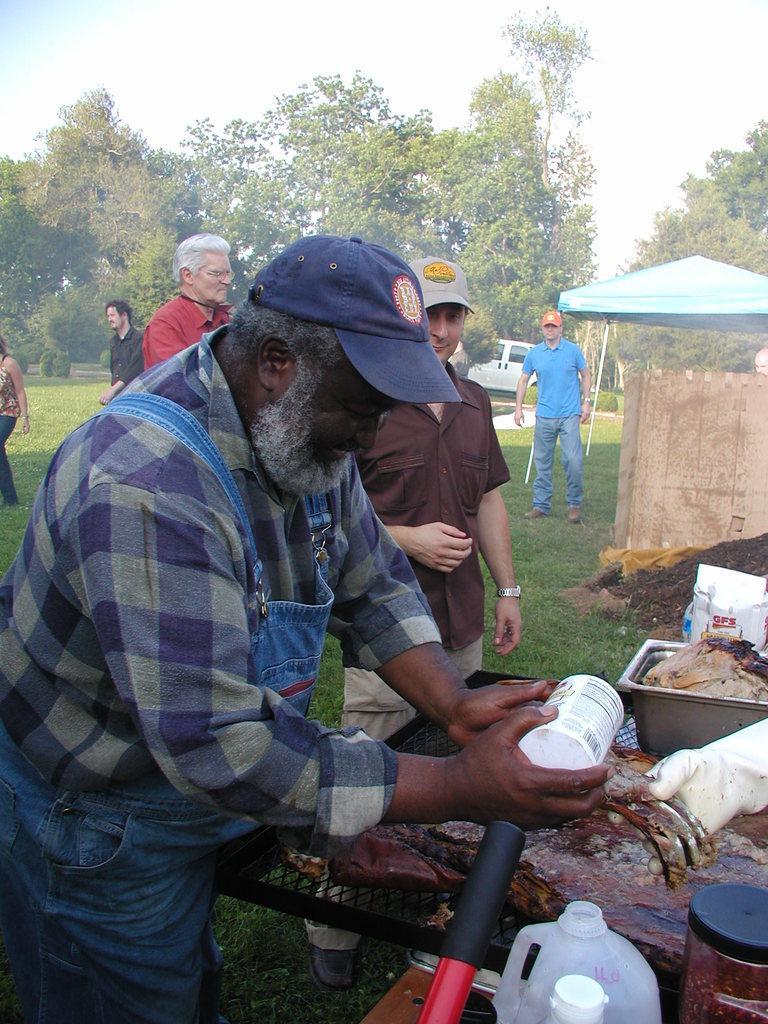Describe this image in one or two sentences. In this picture we can see a group of people standing and here in front person is holding bottle in his hand and beside to him we can see can, net and in the background we can see car, tent, trees, sky. 